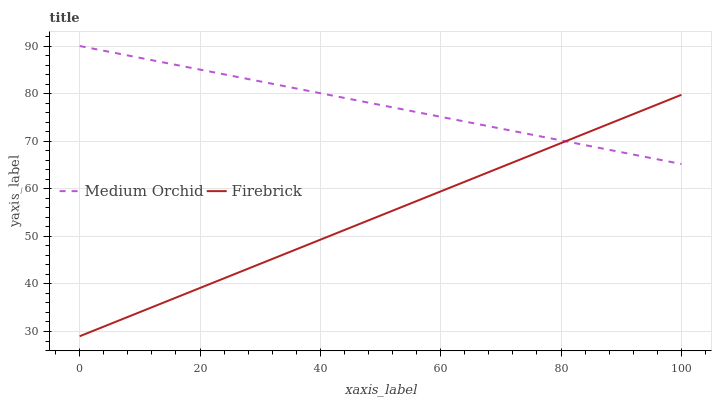Does Medium Orchid have the minimum area under the curve?
Answer yes or no. No. Is Medium Orchid the smoothest?
Answer yes or no. No. Does Medium Orchid have the lowest value?
Answer yes or no. No. 